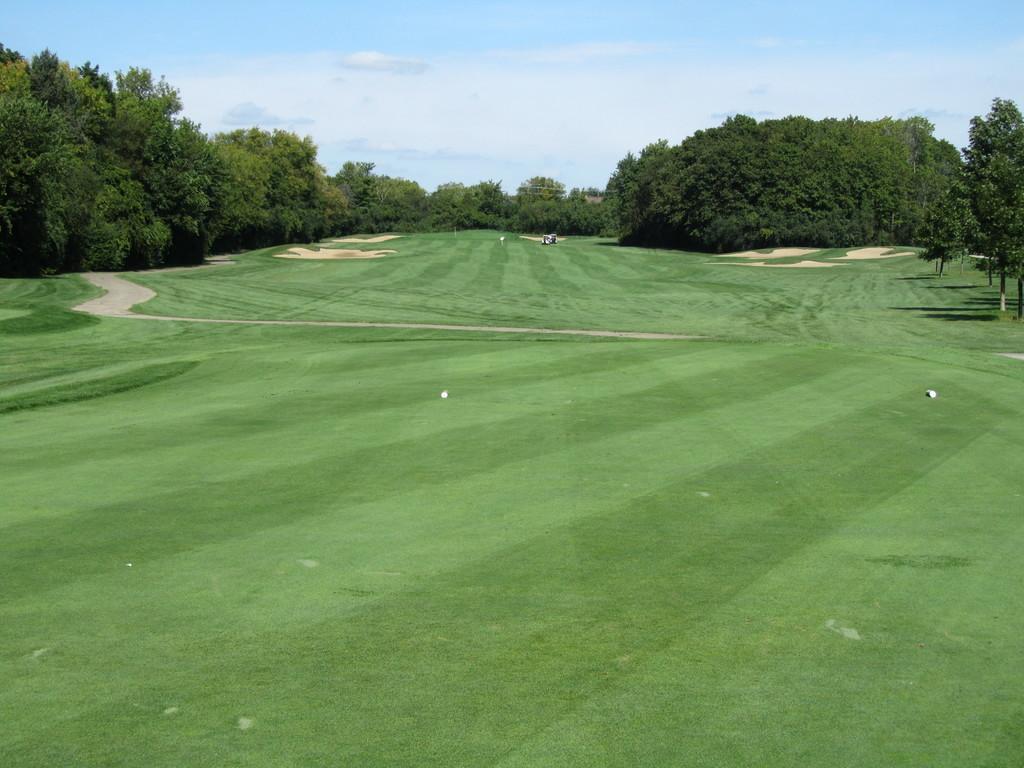Describe this image in one or two sentences. In this picture there is a ground. On the ground there are some objects. In the center there is a lane. On the top there are trees and a sky with clouds. 